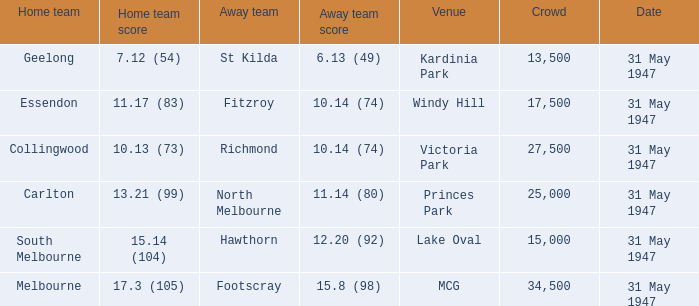What day is south melbourne at home? 31 May 1947. Help me parse the entirety of this table. {'header': ['Home team', 'Home team score', 'Away team', 'Away team score', 'Venue', 'Crowd', 'Date'], 'rows': [['Geelong', '7.12 (54)', 'St Kilda', '6.13 (49)', 'Kardinia Park', '13,500', '31 May 1947'], ['Essendon', '11.17 (83)', 'Fitzroy', '10.14 (74)', 'Windy Hill', '17,500', '31 May 1947'], ['Collingwood', '10.13 (73)', 'Richmond', '10.14 (74)', 'Victoria Park', '27,500', '31 May 1947'], ['Carlton', '13.21 (99)', 'North Melbourne', '11.14 (80)', 'Princes Park', '25,000', '31 May 1947'], ['South Melbourne', '15.14 (104)', 'Hawthorn', '12.20 (92)', 'Lake Oval', '15,000', '31 May 1947'], ['Melbourne', '17.3 (105)', 'Footscray', '15.8 (98)', 'MCG', '34,500', '31 May 1947']]} 